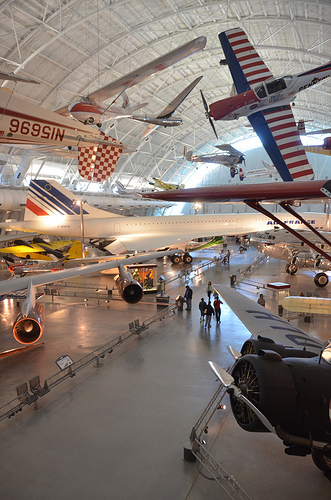<image>
Is there a ceiling to the left of the airplane? No. The ceiling is not to the left of the airplane. From this viewpoint, they have a different horizontal relationship. 